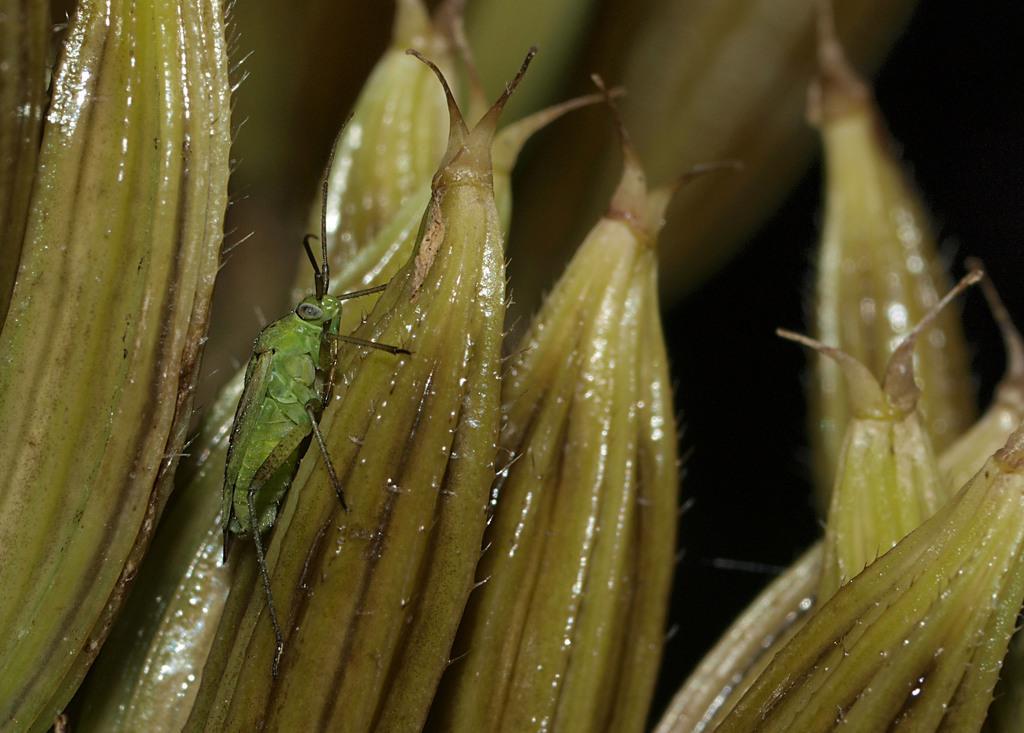Describe this image in one or two sentences. In this picture we can see the light green shining objects and we can see a grasshopper. 